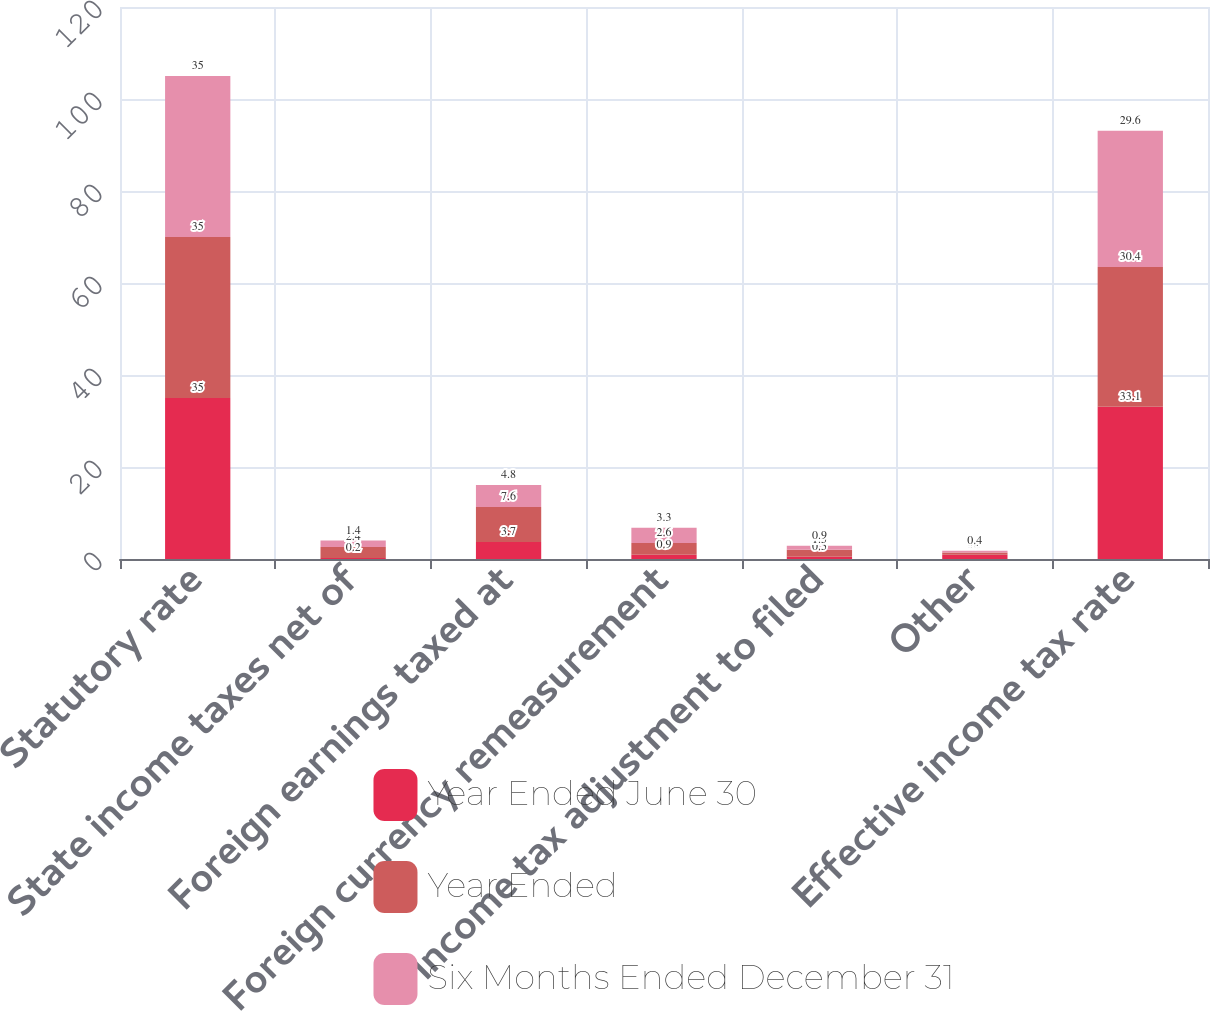Convert chart to OTSL. <chart><loc_0><loc_0><loc_500><loc_500><stacked_bar_chart><ecel><fcel>Statutory rate<fcel>State income taxes net of<fcel>Foreign earnings taxed at<fcel>Foreign currency remeasurement<fcel>Income tax adjustment to filed<fcel>Other<fcel>Effective income tax rate<nl><fcel>Year Ended June 30<fcel>35<fcel>0.2<fcel>3.7<fcel>0.9<fcel>0.5<fcel>0.9<fcel>33.1<nl><fcel>Year Ended<fcel>35<fcel>2.4<fcel>7.6<fcel>2.6<fcel>1.5<fcel>0.5<fcel>30.4<nl><fcel>Six Months Ended December 31<fcel>35<fcel>1.4<fcel>4.8<fcel>3.3<fcel>0.9<fcel>0.4<fcel>29.6<nl></chart> 